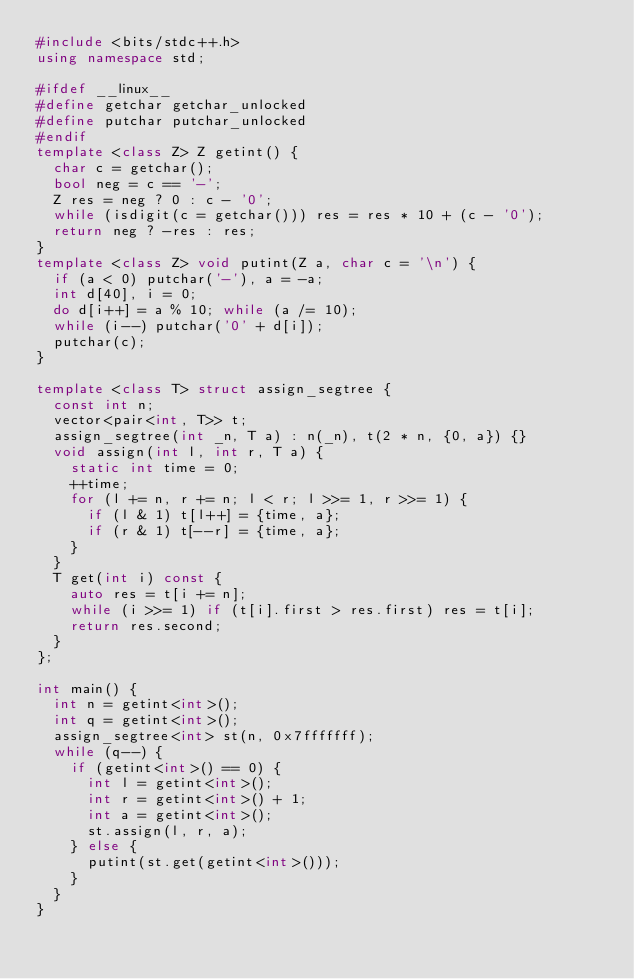<code> <loc_0><loc_0><loc_500><loc_500><_C++_>#include <bits/stdc++.h>
using namespace std;

#ifdef __linux__
#define getchar getchar_unlocked
#define putchar putchar_unlocked
#endif
template <class Z> Z getint() {
  char c = getchar();
  bool neg = c == '-';
  Z res = neg ? 0 : c - '0';
  while (isdigit(c = getchar())) res = res * 10 + (c - '0');
  return neg ? -res : res;
}
template <class Z> void putint(Z a, char c = '\n') {
  if (a < 0) putchar('-'), a = -a;
  int d[40], i = 0;
  do d[i++] = a % 10; while (a /= 10);
  while (i--) putchar('0' + d[i]);
  putchar(c);
}

template <class T> struct assign_segtree {
  const int n;
  vector<pair<int, T>> t;
  assign_segtree(int _n, T a) : n(_n), t(2 * n, {0, a}) {}
  void assign(int l, int r, T a) {
    static int time = 0;
    ++time;
    for (l += n, r += n; l < r; l >>= 1, r >>= 1) {
      if (l & 1) t[l++] = {time, a};
      if (r & 1) t[--r] = {time, a};
    }
  }
  T get(int i) const {
    auto res = t[i += n];
    while (i >>= 1) if (t[i].first > res.first) res = t[i];
    return res.second;
  }
};

int main() {
  int n = getint<int>();
  int q = getint<int>();
  assign_segtree<int> st(n, 0x7fffffff);
  while (q--) {
    if (getint<int>() == 0) {
      int l = getint<int>();
      int r = getint<int>() + 1;
      int a = getint<int>();
      st.assign(l, r, a);
    } else {
      putint(st.get(getint<int>()));
    }
  }
}

</code> 